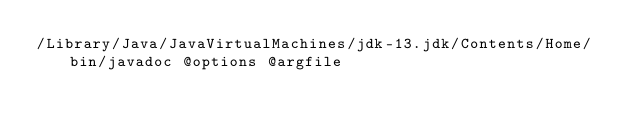Convert code to text. <code><loc_0><loc_0><loc_500><loc_500><_Bash_>/Library/Java/JavaVirtualMachines/jdk-13.jdk/Contents/Home/bin/javadoc @options @argfile</code> 